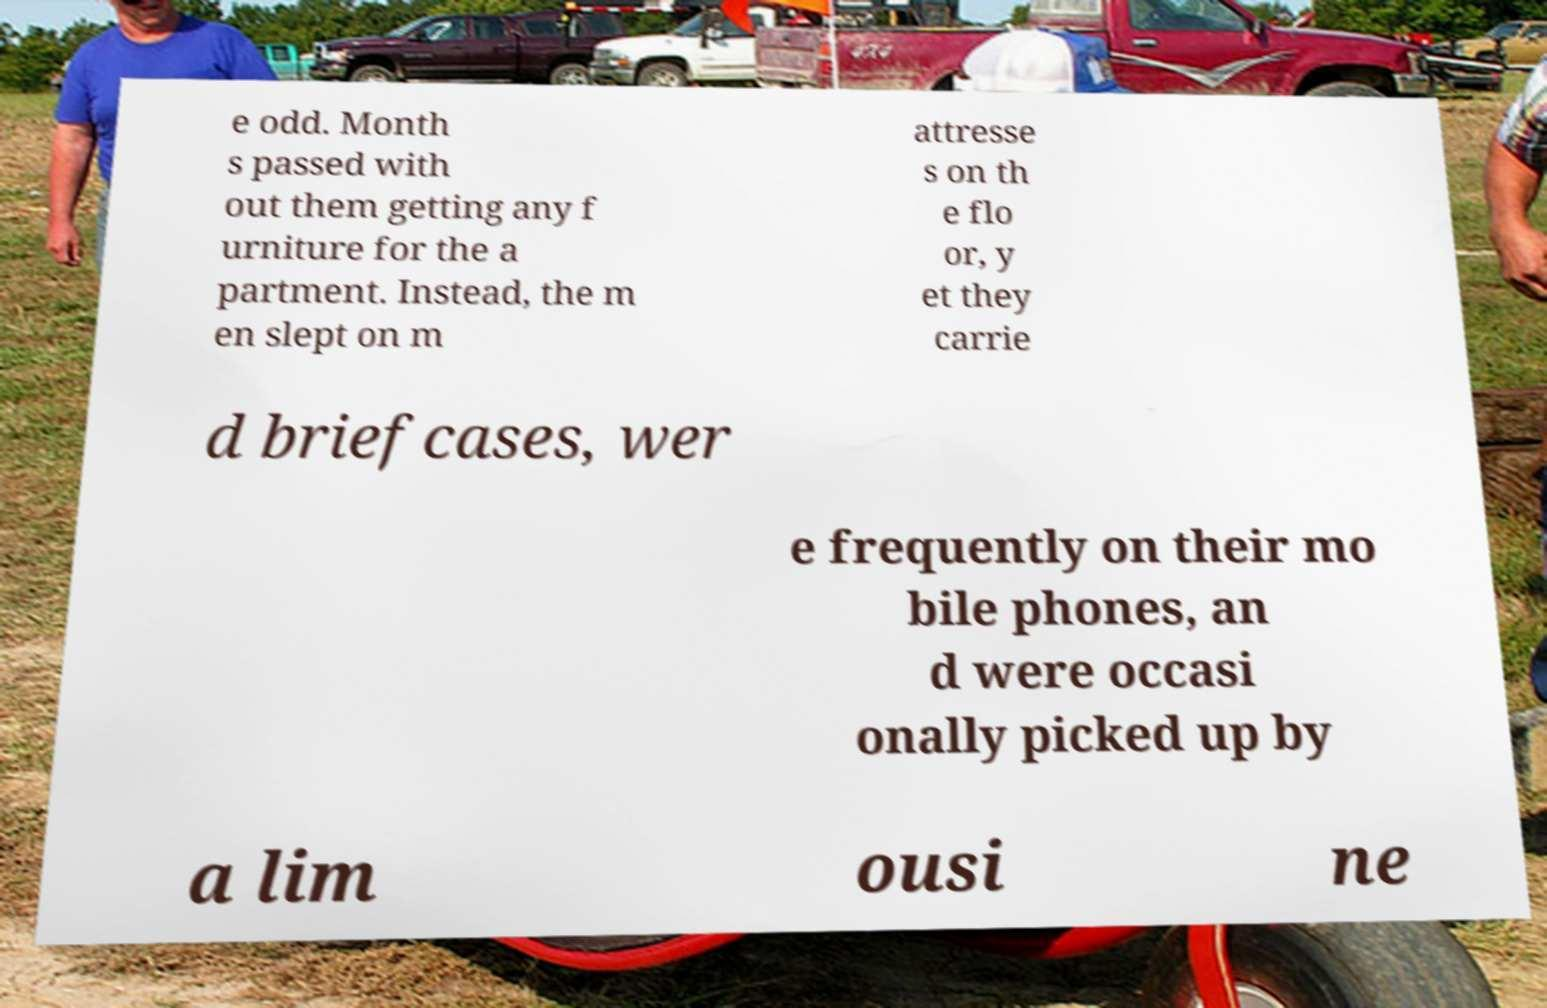Can you accurately transcribe the text from the provided image for me? e odd. Month s passed with out them getting any f urniture for the a partment. Instead, the m en slept on m attresse s on th e flo or, y et they carrie d briefcases, wer e frequently on their mo bile phones, an d were occasi onally picked up by a lim ousi ne 